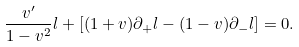Convert formula to latex. <formula><loc_0><loc_0><loc_500><loc_500>\frac { v ^ { \prime } } { 1 - v ^ { 2 } } l + [ ( 1 + v ) \partial _ { + } l - ( 1 - v ) \partial _ { - } l ] = 0 .</formula> 